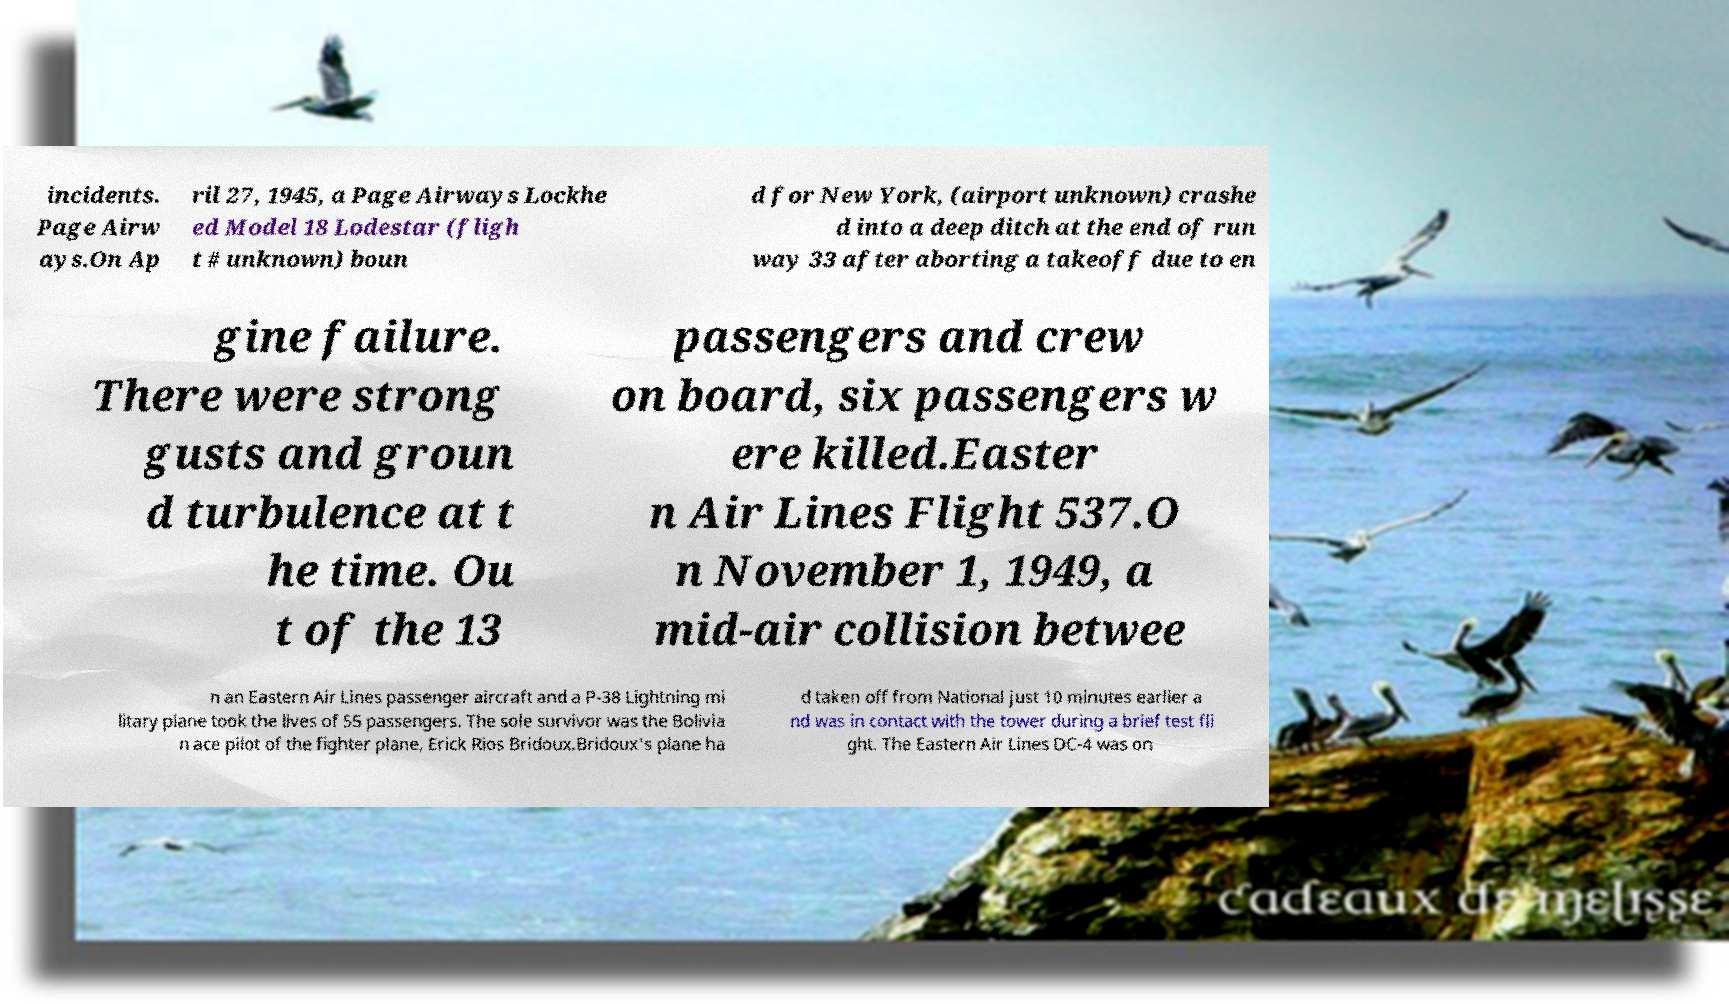For documentation purposes, I need the text within this image transcribed. Could you provide that? incidents. Page Airw ays.On Ap ril 27, 1945, a Page Airways Lockhe ed Model 18 Lodestar (fligh t # unknown) boun d for New York, (airport unknown) crashe d into a deep ditch at the end of run way 33 after aborting a takeoff due to en gine failure. There were strong gusts and groun d turbulence at t he time. Ou t of the 13 passengers and crew on board, six passengers w ere killed.Easter n Air Lines Flight 537.O n November 1, 1949, a mid-air collision betwee n an Eastern Air Lines passenger aircraft and a P-38 Lightning mi litary plane took the lives of 55 passengers. The sole survivor was the Bolivia n ace pilot of the fighter plane, Erick Rios Bridoux.Bridoux's plane ha d taken off from National just 10 minutes earlier a nd was in contact with the tower during a brief test fli ght. The Eastern Air Lines DC-4 was on 